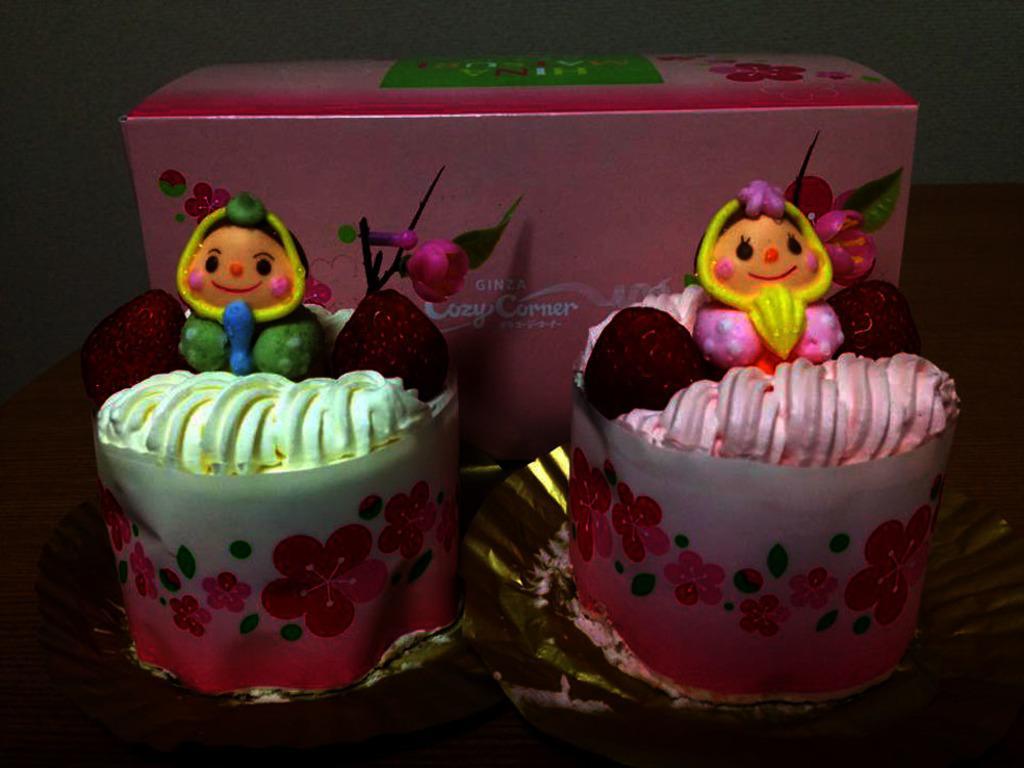In one or two sentences, can you explain what this image depicts? This is a zoomed in picture. In the foreground we can see the two cupcakes and there is a pink color box and we can see the text. In the background there is an object seems to be a wall. 